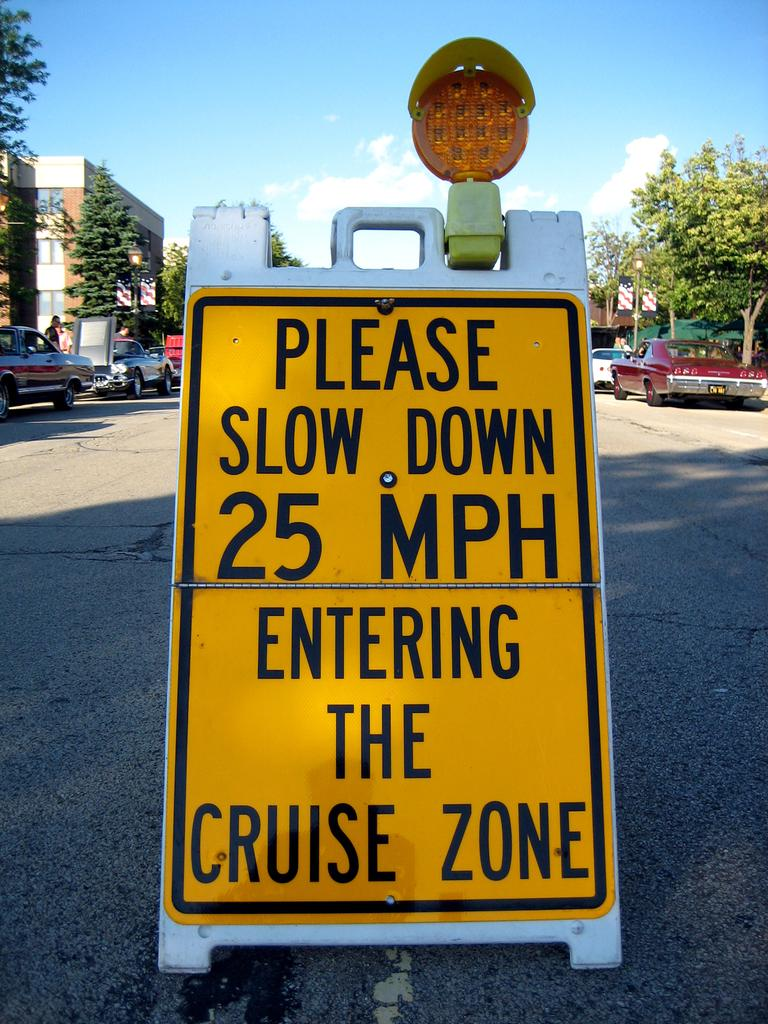Provide a one-sentence caption for the provided image. A yellow road signs reads "please slow down 25mph entering the cruise zone". 